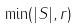<formula> <loc_0><loc_0><loc_500><loc_500>\min ( | S | , r )</formula> 